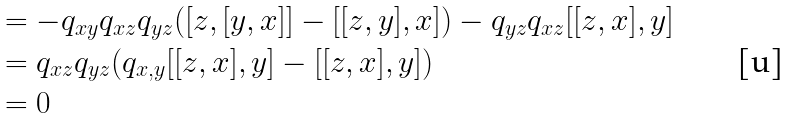<formula> <loc_0><loc_0><loc_500><loc_500>& = - q _ { x y } q _ { x z } q _ { y z } ( [ z , [ y , x ] ] - [ [ z , y ] , x ] ) - q _ { y z } q _ { x z } [ [ z , x ] , y ] \\ & = q _ { x z } q _ { y z } ( q _ { x , y } [ [ z , x ] , y ] - [ [ z , x ] , y ] ) \\ & = 0</formula> 